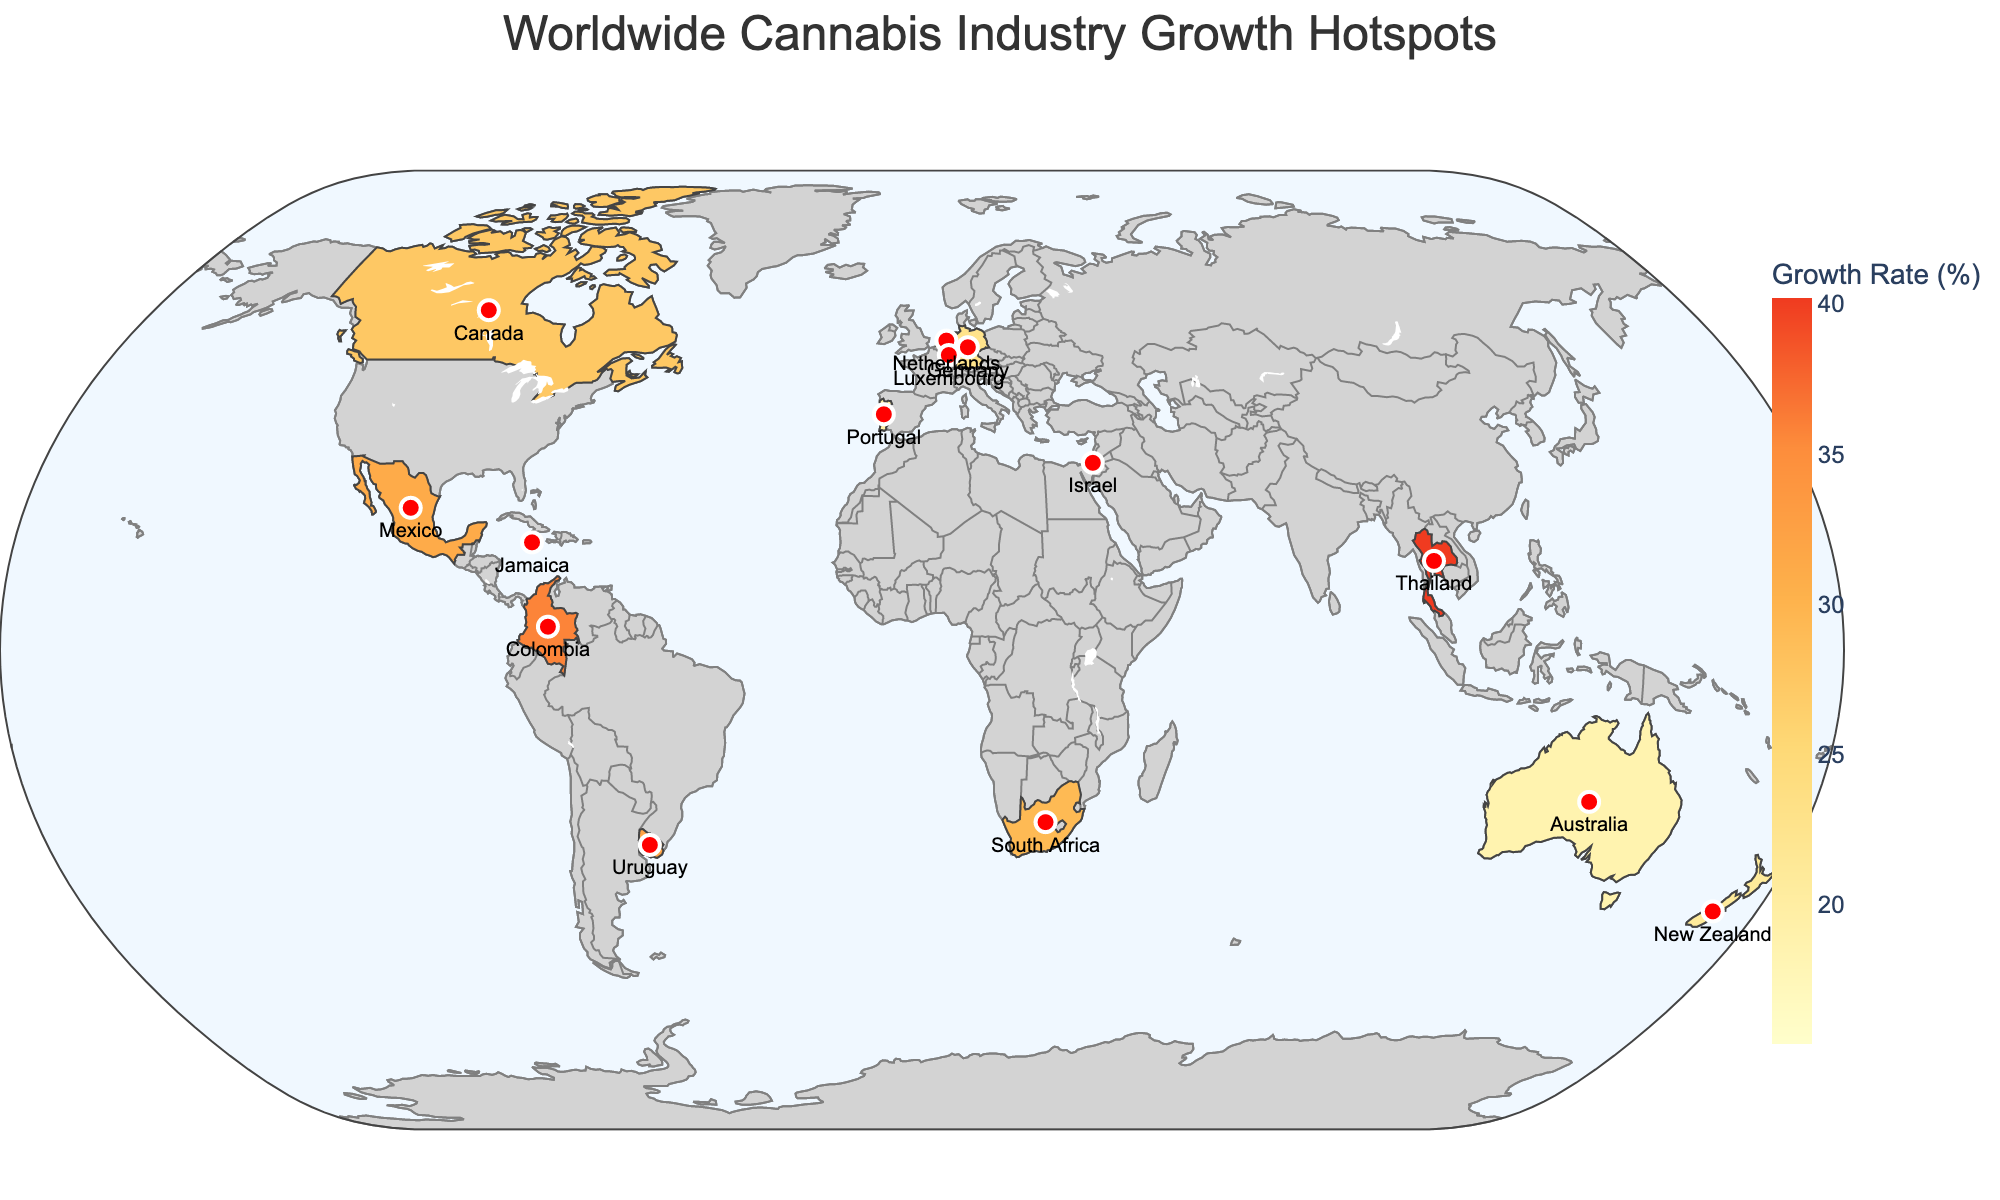Which country in Southeast Asia has the highest cannabis industry growth rate? The figure shows Thailand in Southeast Asia, and when you check its growth rate, it is the highest at 40.2%.
Answer: Thailand What is the title of the figure? The title is provided at the top of the figure, which reads "Worldwide Cannabis Industry Growth Hotspots".
Answer: Worldwide Cannabis Industry Growth Hotspots Among the countries listed, which one has the smallest market size? By referencing the market size information in the figure, Malta has the smallest market size of 50 USD million.
Answer: Malta What is the market size of the cannabis industry in Germany? Locate Germany on the map and check the hover data, which shows a market size of 1600 USD million.
Answer: 1600 USD million Which region has the country with the earliest year of cannabis legalization according to the figure? By reviewing the "Year of Legalization" data for each region, the Netherlands in Europe legalized cannabis in 1976, which is the earliest.
Answer: Europe How does the growth rate of Uruguay compare to that of Jamaica? Checking the growth rates, Uruguay has a rate of 32.1% while Jamaica has 28.6%. Comparing these, Uruguay's growth rate is higher.
Answer: Uruguay's growth rate is higher What is the average growth rate of the countries in Europe? The countries in Europe are Germany (22.8%), Netherlands (15.4%), Malta (38.7%), and Luxembourg (33.5%), Portugal (19.8%). First, sum these rates: 22.8 + 15.4 + 38.7 + 33.5 + 19.8 = 130.2. Then, divide by the number of countries (5), which gives: 130.2 / 5 = 26.04%.
Answer: 26.04% Which country in Oceania has the higher cannabis industry growth rate, Australia or New Zealand? The figure indicates that Australia's growth rate is 18.7%, and New Zealand's is 20.9%. New Zealand's rate is higher.
Answer: New Zealand What is the combined market size of the cannabis industry for North America as shown in the figure? For North America, the countries are Canada (5500) and Mexico (300). The combined market size is 5500 + 300 = 5800 USD million.
Answer: 5800 USD million Which country in South America shows the highest growth rate of the cannabis industry? By comparing the growth rates of countries in South America, Uruguay (32.1%) and Colombia (35.8%), Colombia has the highest.
Answer: Colombia 